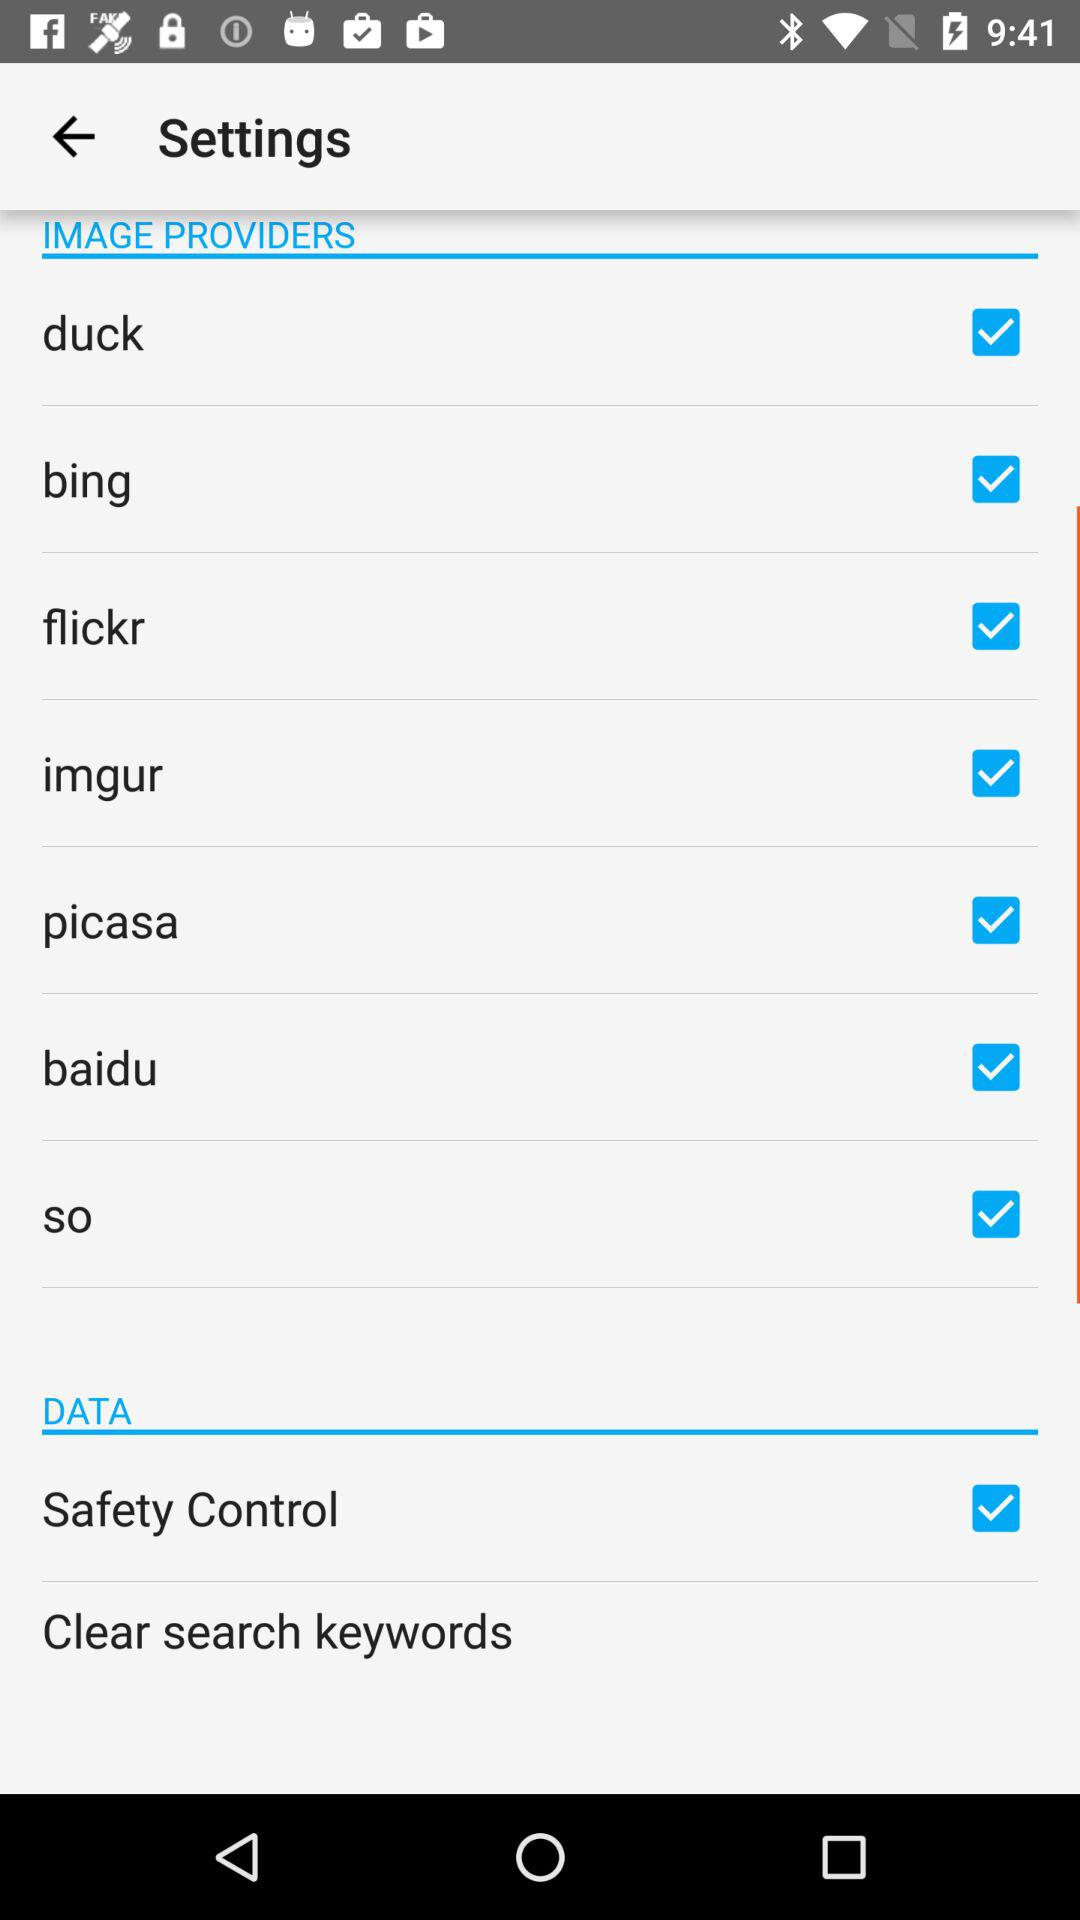What are the checked image providers? The checked image providers are "duck", "bing", "flickr", "imgur", "picasa", "baidu" and "so". 